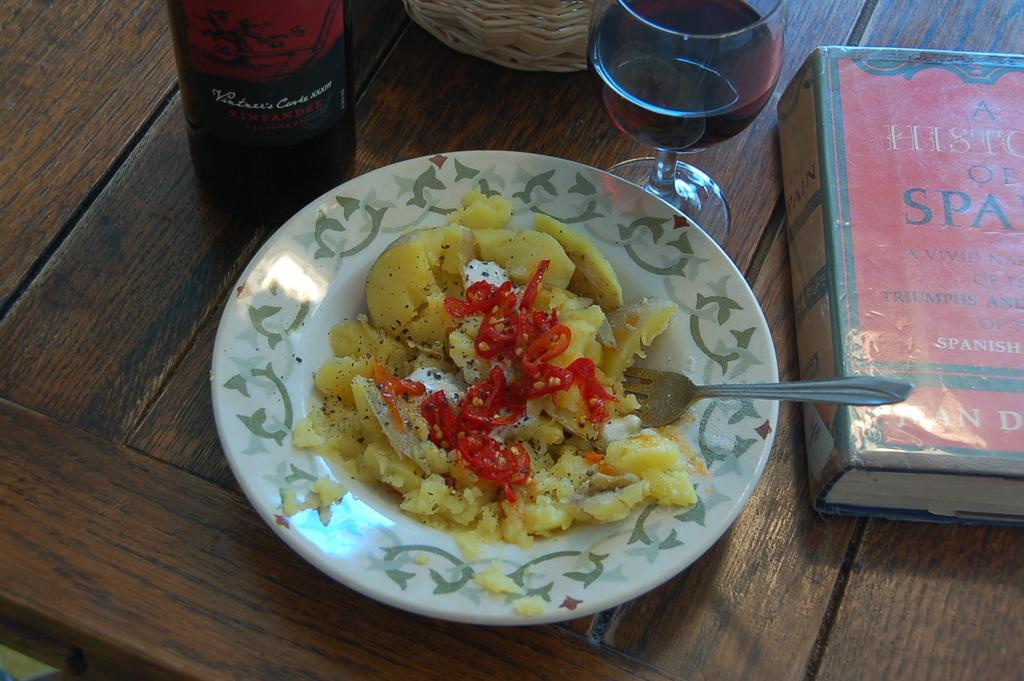Describe this image in one or two sentences. In this image, we can see a table contains bottle, glass, book and plate with some food. There is a fork in the middle of the image. 